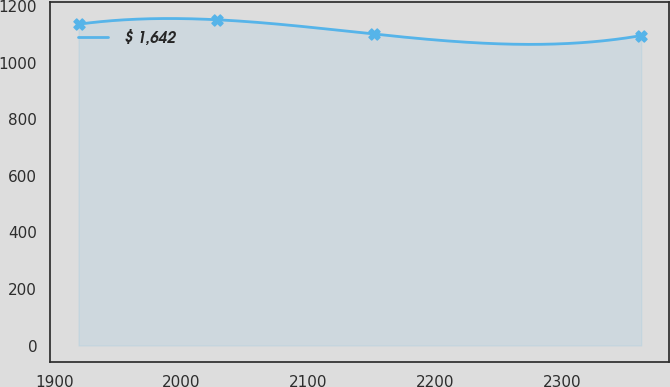Convert chart. <chart><loc_0><loc_0><loc_500><loc_500><line_chart><ecel><fcel>$ 1,642<nl><fcel>1919.18<fcel>1135.82<nl><fcel>2027.8<fcel>1151.68<nl><fcel>2151.27<fcel>1101.3<nl><fcel>2361.82<fcel>1095.7<nl></chart> 